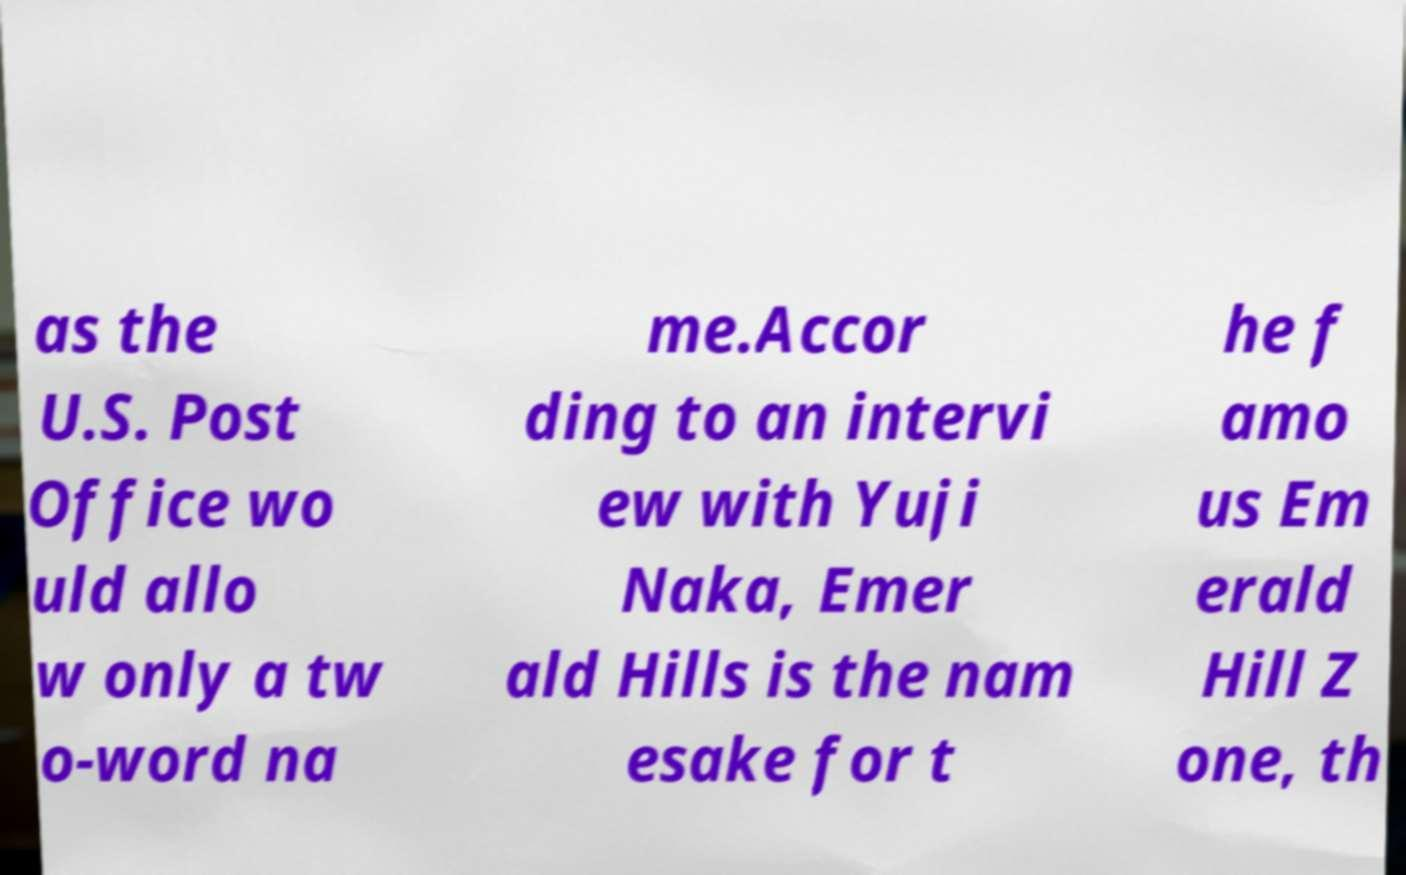I need the written content from this picture converted into text. Can you do that? as the U.S. Post Office wo uld allo w only a tw o-word na me.Accor ding to an intervi ew with Yuji Naka, Emer ald Hills is the nam esake for t he f amo us Em erald Hill Z one, th 